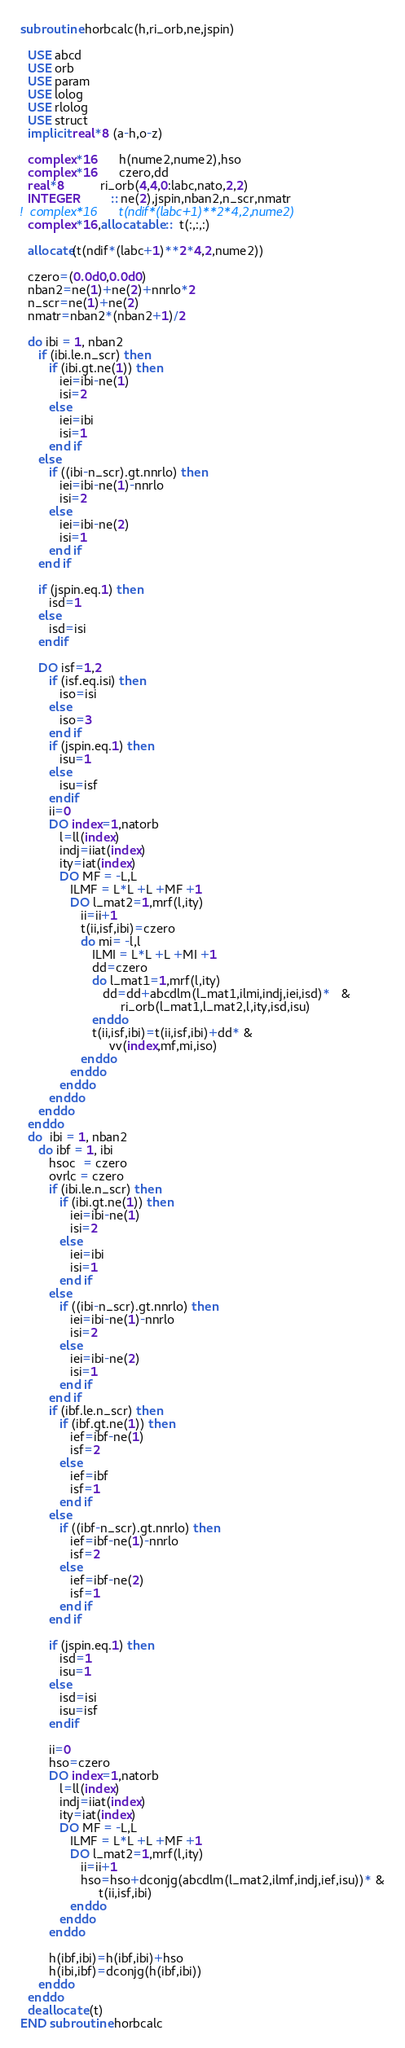<code> <loc_0><loc_0><loc_500><loc_500><_FORTRAN_>subroutine horbcalc(h,ri_orb,ne,jspin)
  
  USE abcd
  USE orb
  USE param
  USE lolog
  USE rlolog
  USE struct
  implicit real*8 (a-h,o-z)
  
  complex*16      h(nume2,nume2),hso
  complex*16      czero,dd
  real*8          ri_orb(4,4,0:labc,nato,2,2)   
  INTEGER         :: ne(2),jspin,nban2,n_scr,nmatr
!  complex*16      t(ndif*(labc+1)**2*4,2,nume2)   
  complex*16,allocatable ::  t(:,:,:)   

  allocate(t(ndif*(labc+1)**2*4,2,nume2))   

  czero=(0.0d0,0.0d0)
  nban2=ne(1)+ne(2)+nnrlo*2
  n_scr=ne(1)+ne(2)
  nmatr=nban2*(nban2+1)/2
  
  do ibi = 1, nban2
     if (ibi.le.n_scr) then
        if (ibi.gt.ne(1)) then
           iei=ibi-ne(1)
           isi=2
        else
           iei=ibi
           isi=1
        end if
     else
        if ((ibi-n_scr).gt.nnrlo) then
           iei=ibi-ne(1)-nnrlo
           isi=2
        else
           iei=ibi-ne(2)
           isi=1
        end if
     end if
       
     if (jspin.eq.1) then
        isd=1
     else
        isd=isi
     endif
       
     DO isf=1,2
        if (isf.eq.isi) then
           iso=isi
        else
           iso=3
        end if
        if (jspin.eq.1) then
           isu=1
        else
           isu=isf
        endif
        ii=0
        DO index=1,natorb
           l=ll(index)
           indj=iiat(index)
           ity=iat(index)
           DO MF = -L,L
              ILMF = L*L +L +MF +1
              DO l_mat2=1,mrf(l,ity)
                 ii=ii+1
                 t(ii,isf,ibi)=czero
                 do mi= -l,l
                    ILMI = L*L +L +MI +1
                    dd=czero
                    do l_mat1=1,mrf(l,ity)
                       dd=dd+abcdlm(l_mat1,ilmi,indj,iei,isd)*   &
                            ri_orb(l_mat1,l_mat2,l,ity,isd,isu)
                    enddo
                    t(ii,isf,ibi)=t(ii,isf,ibi)+dd* &
                         vv(index,mf,mi,iso) 
                 enddo
              enddo
           enddo
        enddo
     enddo
  enddo
  do  ibi = 1, nban2
     do ibf = 1, ibi
        hsoc  = czero
        ovrlc = czero
        if (ibi.le.n_scr) then
           if (ibi.gt.ne(1)) then
              iei=ibi-ne(1)
              isi=2
           else
              iei=ibi
              isi=1
           end if
        else
           if ((ibi-n_scr).gt.nnrlo) then
              iei=ibi-ne(1)-nnrlo
              isi=2
           else
              iei=ibi-ne(2)
              isi=1
           end if
        end if
        if (ibf.le.n_scr) then
           if (ibf.gt.ne(1)) then
              ief=ibf-ne(1)
              isf=2
           else
              ief=ibf
              isf=1
           end if
        else
           if ((ibf-n_scr).gt.nnrlo) then
              ief=ibf-ne(1)-nnrlo
              isf=2
           else
              ief=ibf-ne(2)
              isf=1
           end if
        end if
        
        if (jspin.eq.1) then
           isd=1
           isu=1
        else
           isd=isi
           isu=isf
        endif
        
        ii=0
        hso=czero
        DO index=1,natorb
           l=ll(index)
           indj=iiat(index)
           ity=iat(index)
           DO MF = -L,L
              ILMF = L*L +L +MF +1
              DO l_mat2=1,mrf(l,ity)
                 ii=ii+1
                 hso=hso+dconjg(abcdlm(l_mat2,ilmf,indj,ief,isu))* &
                      t(ii,isf,ibi)
              enddo
           enddo
        enddo
        
        h(ibf,ibi)=h(ibf,ibi)+hso
        h(ibi,ibf)=dconjg(h(ibf,ibi))
     enddo
  enddo
  deallocate (t) 
END subroutine horbcalc
</code> 